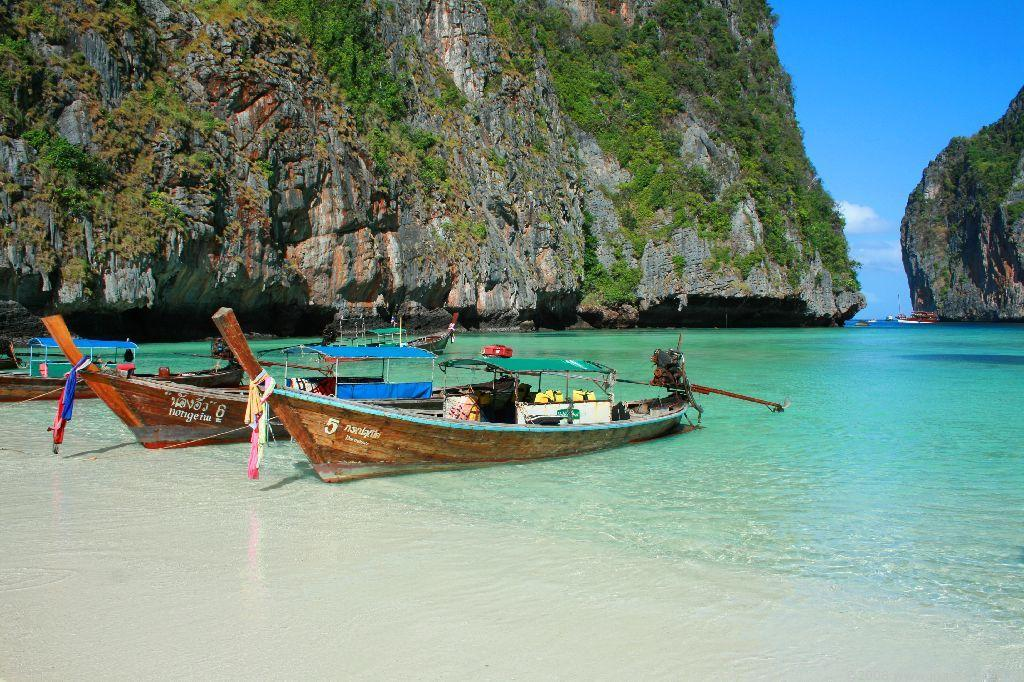Provide a one-sentence caption for the provided image. Boats 5 and 6 are resting in shallow water in the beautiful bay. 